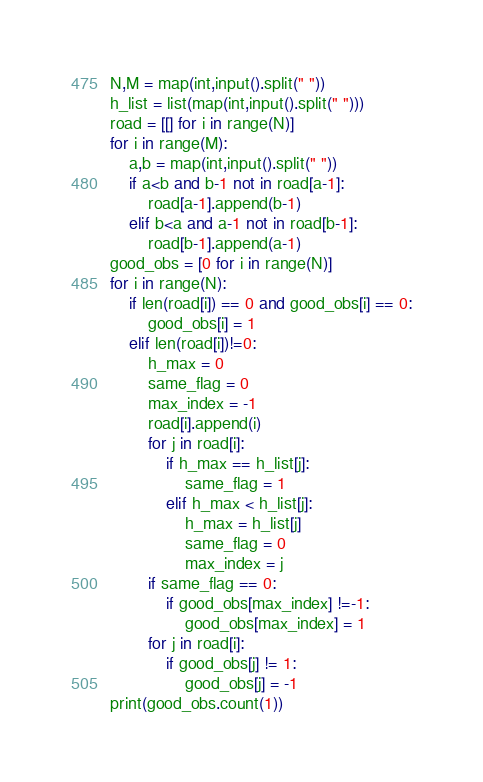Convert code to text. <code><loc_0><loc_0><loc_500><loc_500><_Python_>N,M = map(int,input().split(" "))
h_list = list(map(int,input().split(" ")))
road = [[] for i in range(N)]
for i in range(M):
    a,b = map(int,input().split(" "))
    if a<b and b-1 not in road[a-1]:
        road[a-1].append(b-1)
    elif b<a and a-1 not in road[b-1]:
        road[b-1].append(a-1)
good_obs = [0 for i in range(N)]
for i in range(N):
    if len(road[i]) == 0 and good_obs[i] == 0:
        good_obs[i] = 1
    elif len(road[i])!=0:
        h_max = 0
        same_flag = 0
        max_index = -1
        road[i].append(i)
        for j in road[i]:
            if h_max == h_list[j]:
                same_flag = 1
            elif h_max < h_list[j]:
                h_max = h_list[j]
                same_flag = 0
                max_index = j
        if same_flag == 0:
            if good_obs[max_index] !=-1:
                good_obs[max_index] = 1
        for j in road[i]:
            if good_obs[j] != 1:
                good_obs[j] = -1
print(good_obs.count(1))
</code> 